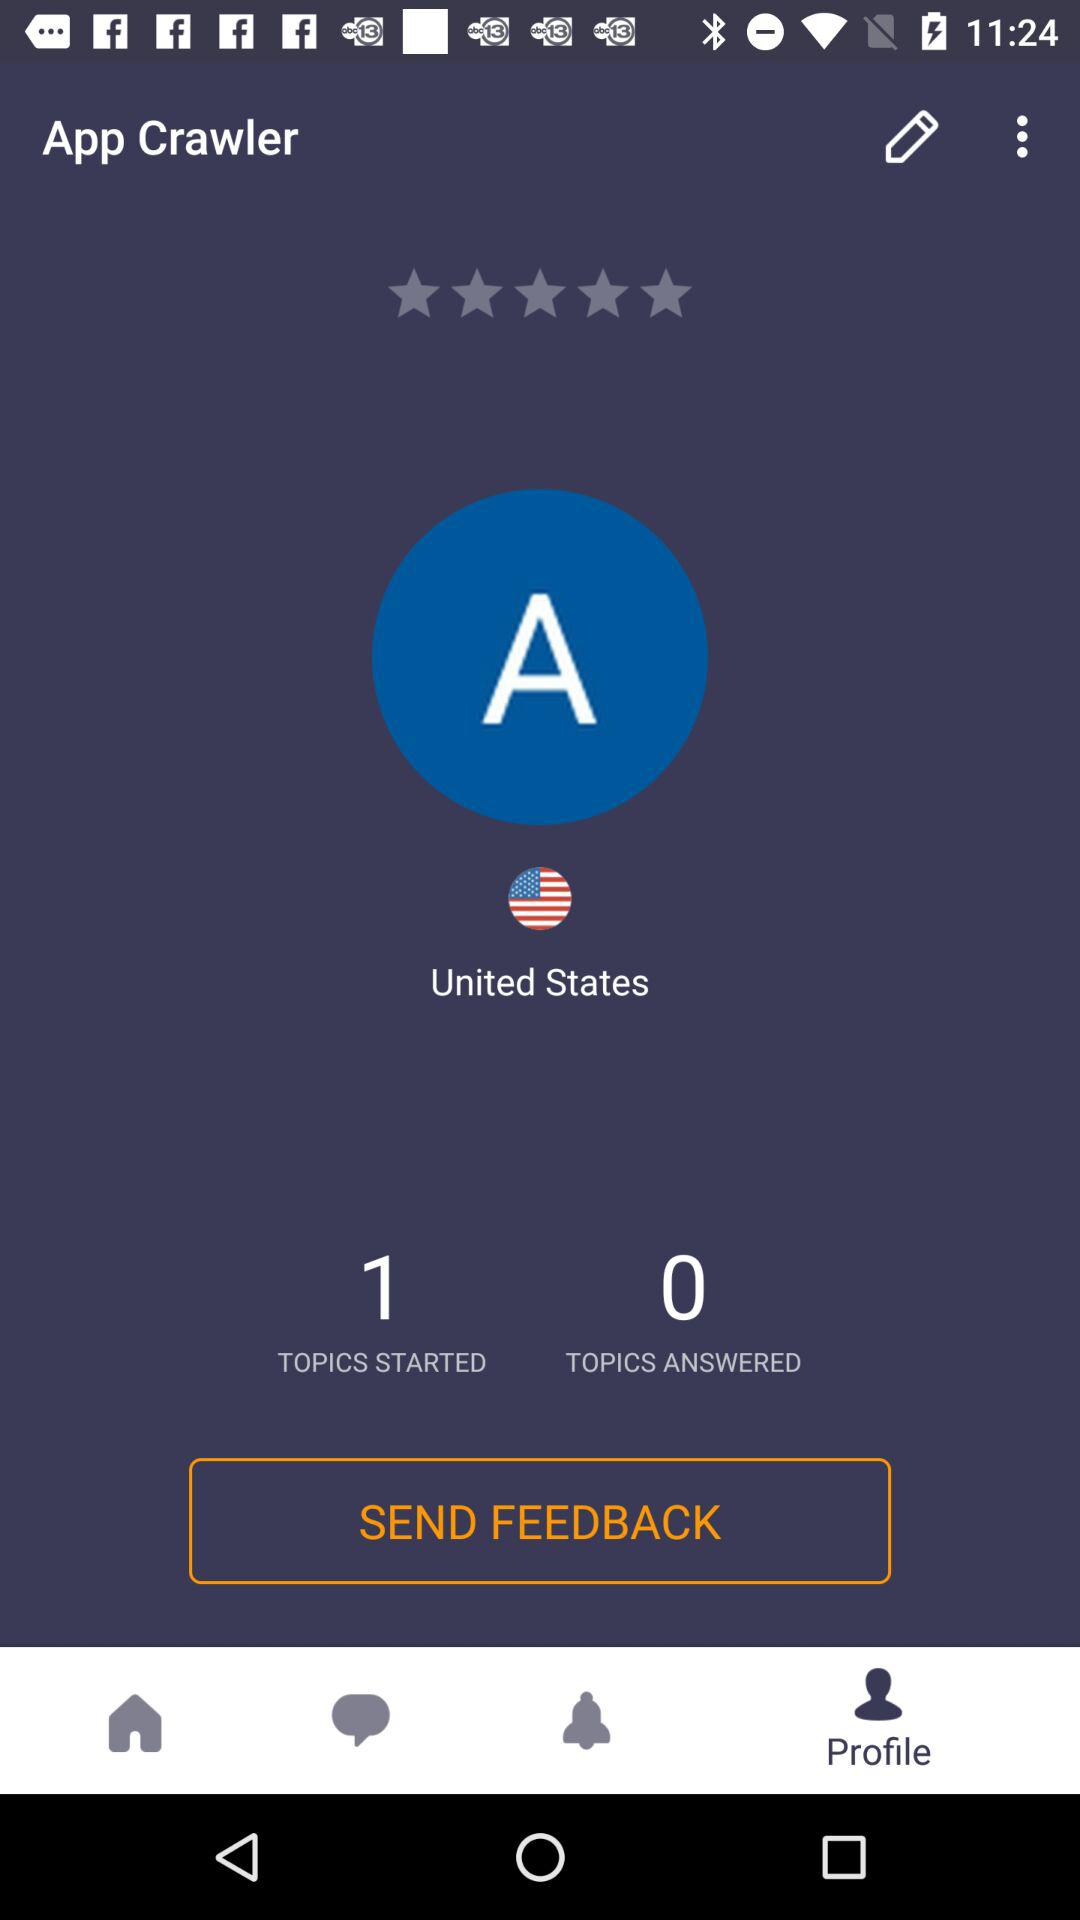How many topics are answered? Topics answered are 0. 